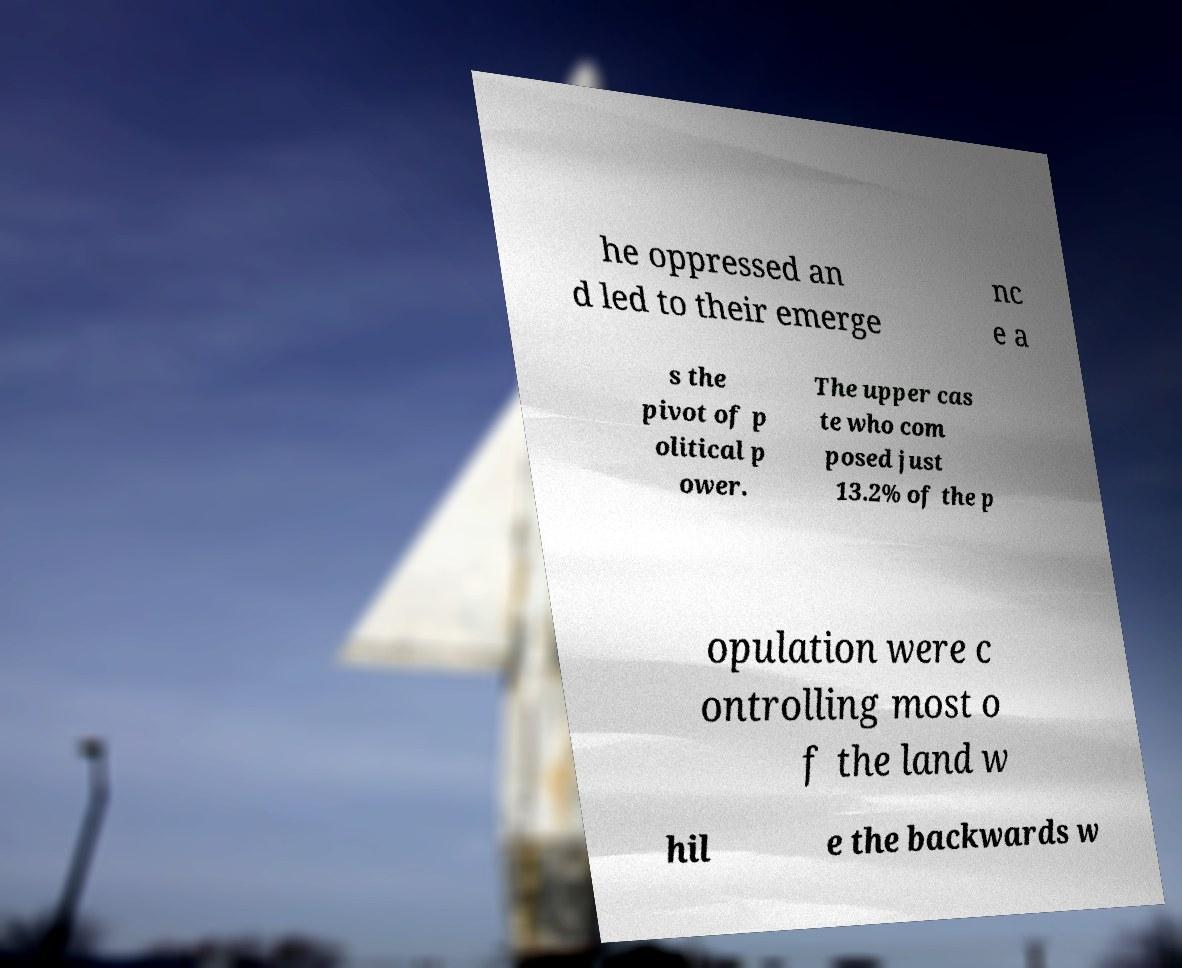I need the written content from this picture converted into text. Can you do that? he oppressed an d led to their emerge nc e a s the pivot of p olitical p ower. The upper cas te who com posed just 13.2% of the p opulation were c ontrolling most o f the land w hil e the backwards w 